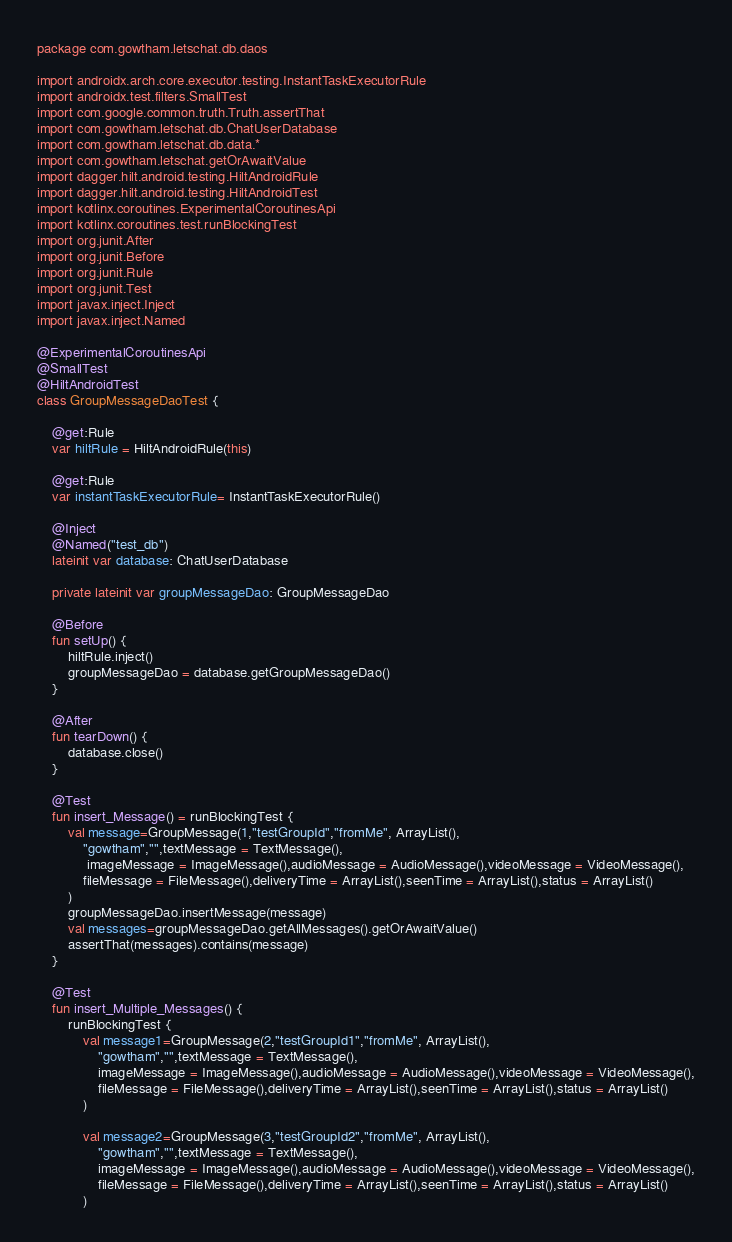Convert code to text. <code><loc_0><loc_0><loc_500><loc_500><_Kotlin_>package com.gowtham.letschat.db.daos

import androidx.arch.core.executor.testing.InstantTaskExecutorRule
import androidx.test.filters.SmallTest
import com.google.common.truth.Truth.assertThat
import com.gowtham.letschat.db.ChatUserDatabase
import com.gowtham.letschat.db.data.*
import com.gowtham.letschat.getOrAwaitValue
import dagger.hilt.android.testing.HiltAndroidRule
import dagger.hilt.android.testing.HiltAndroidTest
import kotlinx.coroutines.ExperimentalCoroutinesApi
import kotlinx.coroutines.test.runBlockingTest
import org.junit.After
import org.junit.Before
import org.junit.Rule
import org.junit.Test
import javax.inject.Inject
import javax.inject.Named

@ExperimentalCoroutinesApi
@SmallTest
@HiltAndroidTest
class GroupMessageDaoTest {

    @get:Rule
    var hiltRule = HiltAndroidRule(this)

    @get:Rule
    var instantTaskExecutorRule= InstantTaskExecutorRule()

    @Inject
    @Named("test_db")
    lateinit var database: ChatUserDatabase

    private lateinit var groupMessageDao: GroupMessageDao

    @Before
    fun setUp() {
        hiltRule.inject()
        groupMessageDao = database.getGroupMessageDao()
    }

    @After
    fun tearDown() {
        database.close()
    }

    @Test
    fun insert_Message() = runBlockingTest {
        val message=GroupMessage(1,"testGroupId","fromMe", ArrayList(),
            "gowtham","",textMessage = TextMessage(),
             imageMessage = ImageMessage(),audioMessage = AudioMessage(),videoMessage = VideoMessage(),
            fileMessage = FileMessage(),deliveryTime = ArrayList(),seenTime = ArrayList(),status = ArrayList()
        )
        groupMessageDao.insertMessage(message)
        val messages=groupMessageDao.getAllMessages().getOrAwaitValue()
        assertThat(messages).contains(message)
    }

    @Test
    fun insert_Multiple_Messages() {
        runBlockingTest {
            val message1=GroupMessage(2,"testGroupId1","fromMe", ArrayList(),
                "gowtham","",textMessage = TextMessage(),
                imageMessage = ImageMessage(),audioMessage = AudioMessage(),videoMessage = VideoMessage(),
                fileMessage = FileMessage(),deliveryTime = ArrayList(),seenTime = ArrayList(),status = ArrayList()
            )

            val message2=GroupMessage(3,"testGroupId2","fromMe", ArrayList(),
                "gowtham","",textMessage = TextMessage(),
                imageMessage = ImageMessage(),audioMessage = AudioMessage(),videoMessage = VideoMessage(),
                fileMessage = FileMessage(),deliveryTime = ArrayList(),seenTime = ArrayList(),status = ArrayList()
            )</code> 